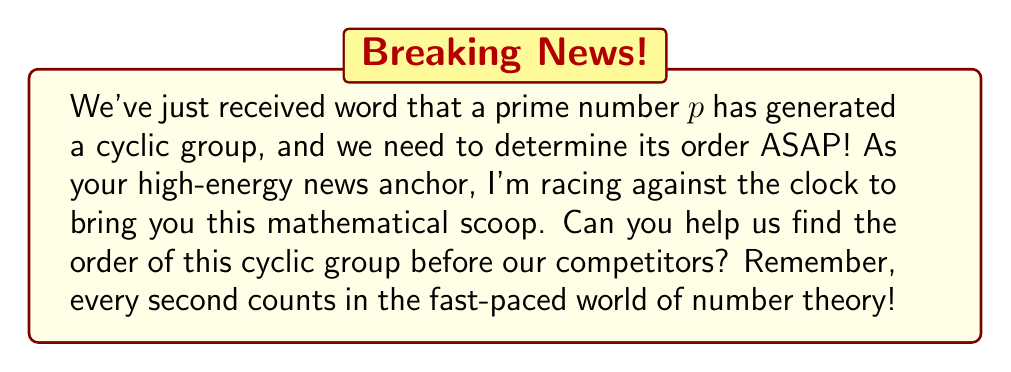Could you help me with this problem? Let's break this down step-by-step, maintaining our composure like we're in a relaxing yoga session:

1) First, recall that a cyclic group is a group that can be generated by a single element. In this case, our generator is a prime number $p$.

2) In a cyclic group, the order of the group is equal to the order of its generator.

3) The order of an element in a group is the smallest positive integer $n$ such that $a^n = e$, where $a$ is the element and $e$ is the identity element.

4) Now, let's consider the properties of prime numbers:
   - A prime number $p$ is only divisible by 1 and itself.
   - In modular arithmetic, $p^p \equiv p \pmod{p}$
   - By Fermat's Little Theorem, for any integer $a$ not divisible by $p$, $a^{p-1} \equiv 1 \pmod{p}$

5) In our cyclic group generated by $p$, the elements will be of the form $p^k \bmod p$ for various values of $k$.

6) The smallest positive $k$ for which $p^k \equiv 1 \pmod{p}$ is $k = p-1$.

7) Therefore, the order of $p$ in this cyclic group is $p-1$.

8) Since the order of the generator is equal to the order of the cyclic group it generates, the order of our cyclic group is also $p-1$.
Answer: The order of the cyclic group generated by a prime number $p$ is $p-1$. 